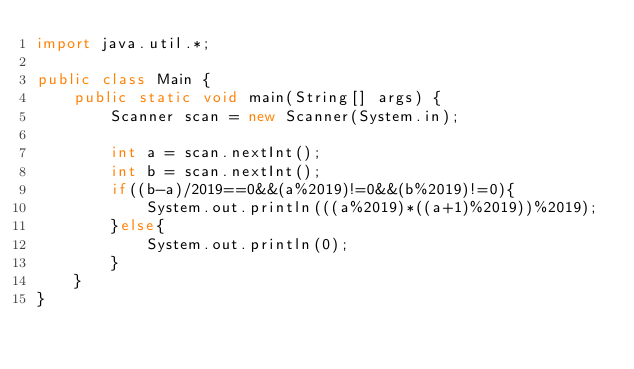<code> <loc_0><loc_0><loc_500><loc_500><_Java_>import java.util.*;
 
public class Main {
    public static void main(String[] args) {
        Scanner scan = new Scanner(System.in);
 
        int a = scan.nextInt();
        int b = scan.nextInt();
        if((b-a)/2019==0&&(a%2019)!=0&&(b%2019)!=0){
            System.out.println(((a%2019)*((a+1)%2019))%2019);
        }else{
            System.out.println(0);
        }
    }
}</code> 